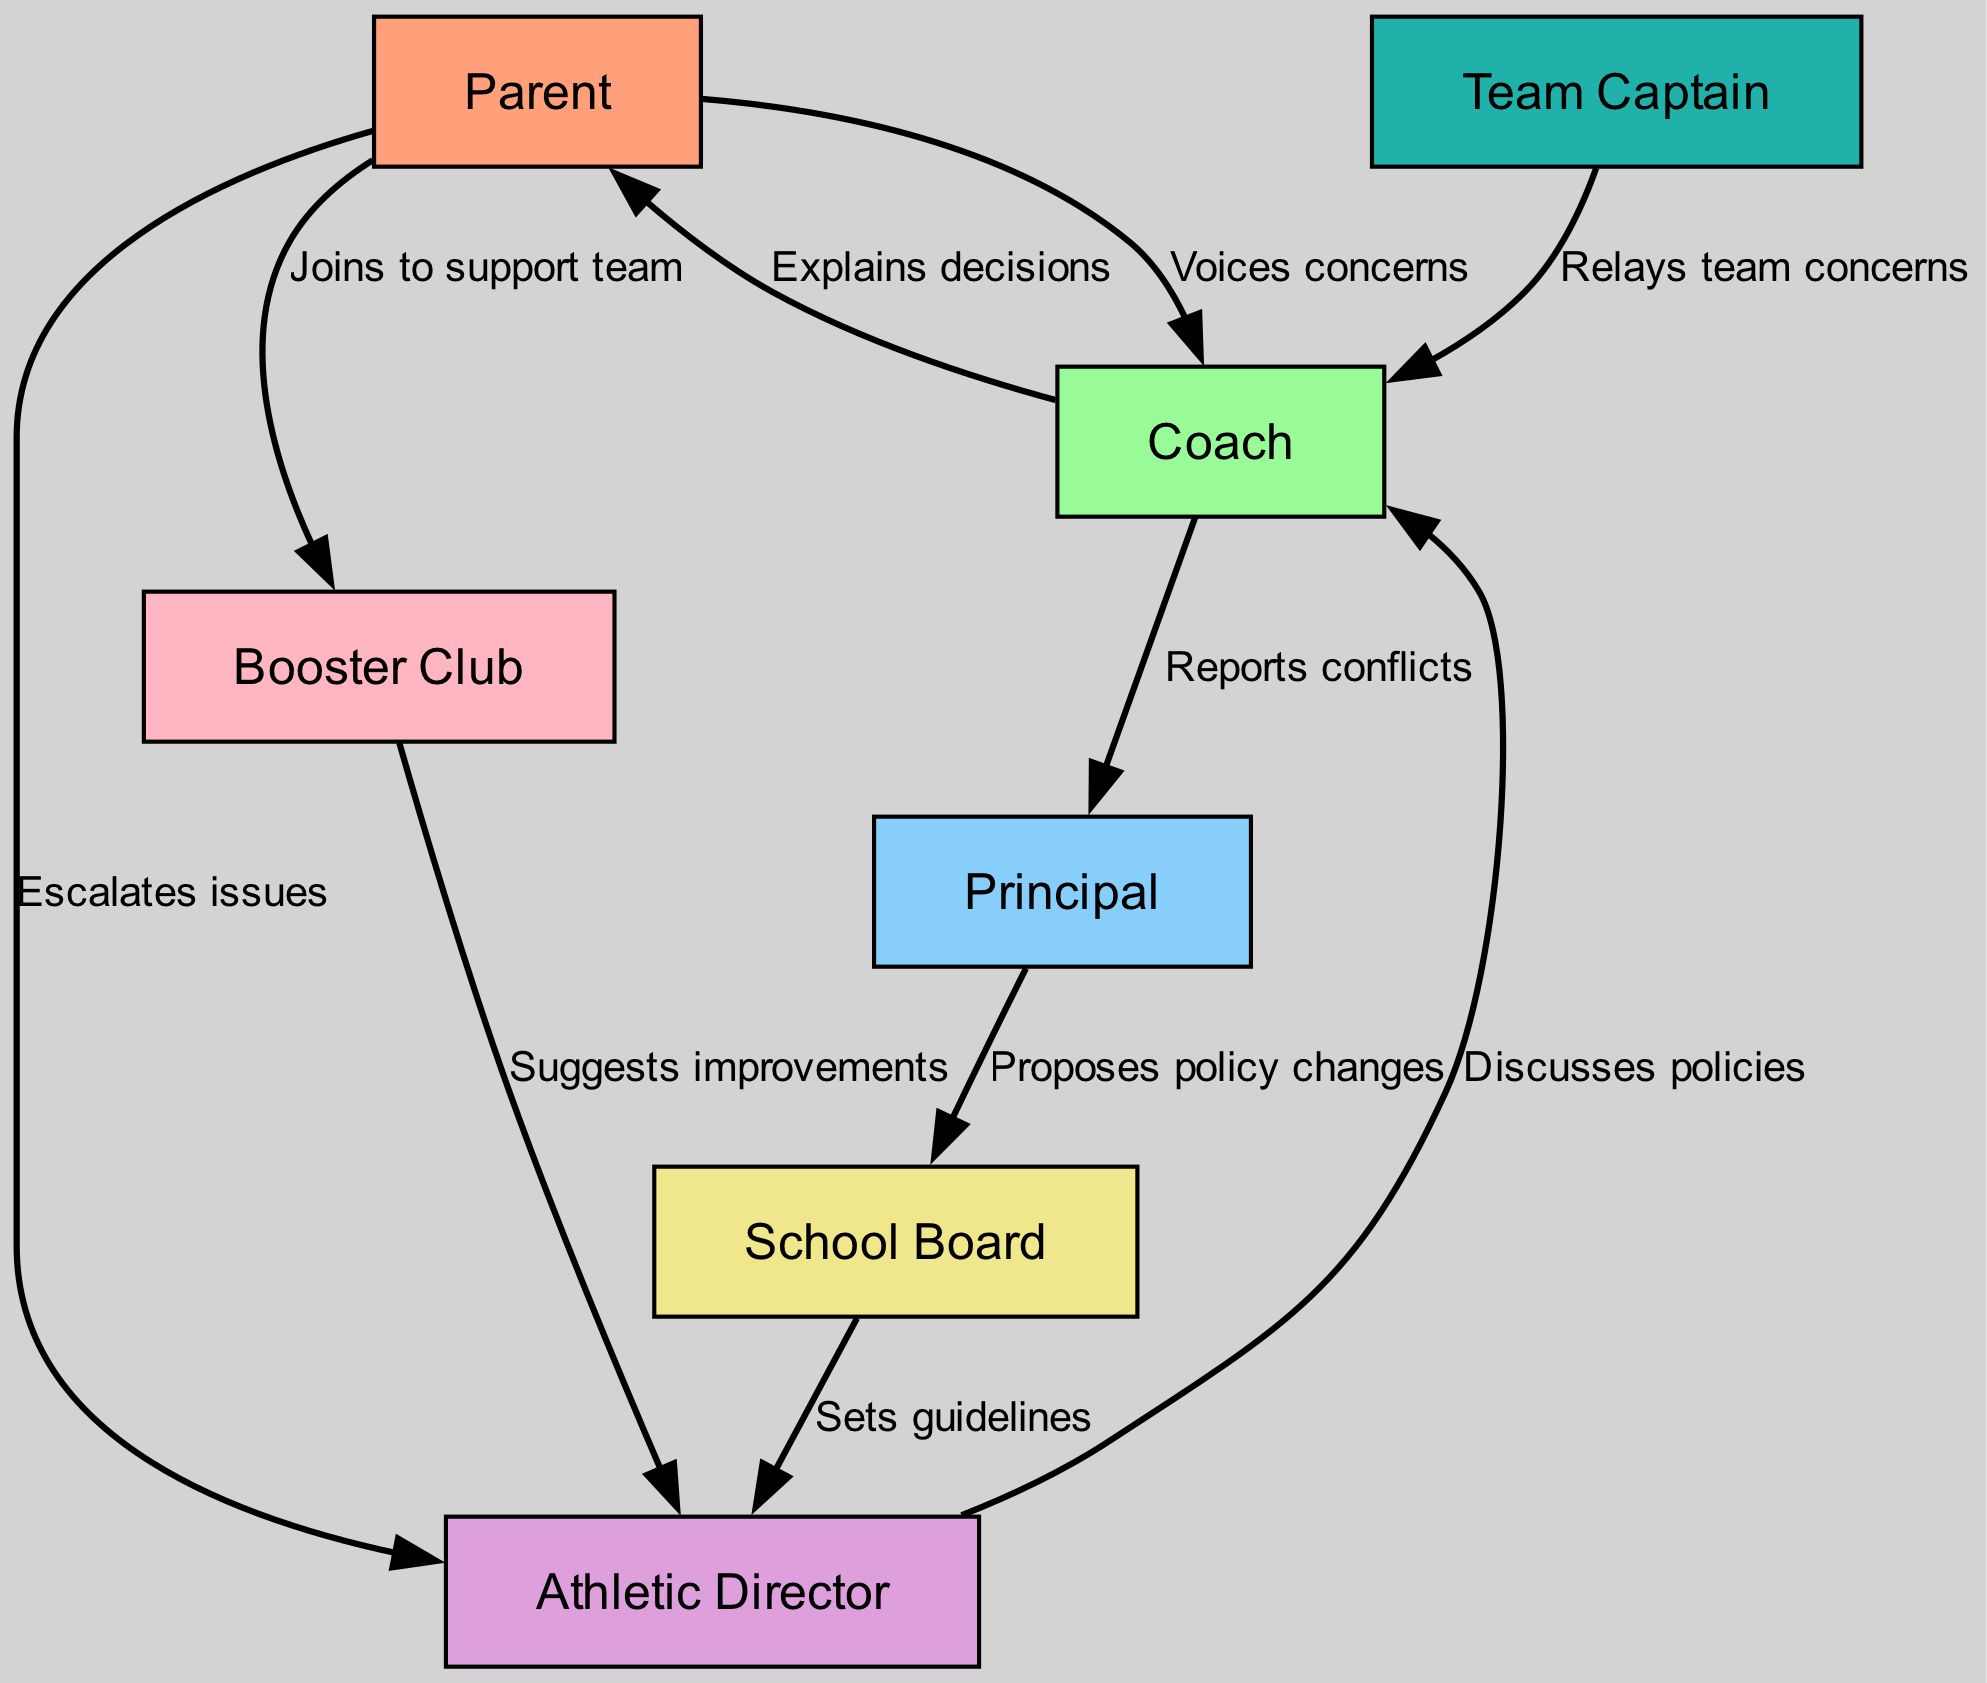What is the total number of nodes in the diagram? In the diagram, the nodes listed are: Parent, Coach, Principal, Athletic Director, School Board, Team Captain, and Booster Club. Counting these gives a total of 7 nodes.
Answer: 7 Which node does the Parent voice concerns to? According to the directed graph, the edge labeled "Voices concerns" connects the Parent node to the Coach node, indicating the Parent communicates concerns directly to the Coach.
Answer: Coach How many edges are connected to the Athletic Director? The Athletic Director has incoming edges from the Parent (escalates issues), the Coach (discusses policies), and the Booster Club (suggests improvements). Counting these gives a total of 3 edges connected to the Athletic Director.
Answer: 3 What relationship does the Booster Club have with the Athletic Director? The edge labeled "Suggests improvements" indicates that the Booster Club communicates suggestions for enhancements to the Athletic Director, showing a supportive communication relationship.
Answer: Suggests improvements Who proposes policy changes to the School Board? The directed edge from the Principal to the School Board is labeled "Proposes policy changes," indicating that the Principal is responsible for proposing such changes to the School Board.
Answer: Principal Which node is the final recipient of policy changes proposed by the Principal? Following the flow, the directed edge from the Principal to the School Board shows that policy changes proposed by the Principal are received by the School Board, making it the last node in this communication chain for policy changes.
Answer: School Board How does the Coach relay team concerns? The Coach receives concerns from the Team Captain as indicated by the directed edge "Relays team concerns," which shows how team feedback is communicated to the Coach.
Answer: Team Captain Which node escalates issues to the Athletic Director? The edge from the Parent to the Athletic Director labeled "Escalates issues" indicates that if parents have concerns, they escalate them directly to the Athletic Director.
Answer: Athletic Director What is the communication flow from the Principal to the School Board? The flow involves the Principal reporting issues to the School Board through a directed edge labeled "Proposes policy changes," summarizing that the Principal initiates discussions regarding changes in policy with the School Board.
Answer: Proposes policy changes 